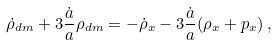<formula> <loc_0><loc_0><loc_500><loc_500>\dot { \rho } _ { d m } + 3 \frac { \dot { a } } { a } \rho _ { d m } = - \dot { \rho } _ { x } - 3 \frac { \dot { a } } { a } ( \rho _ { x } + p _ { x } ) \, ,</formula> 